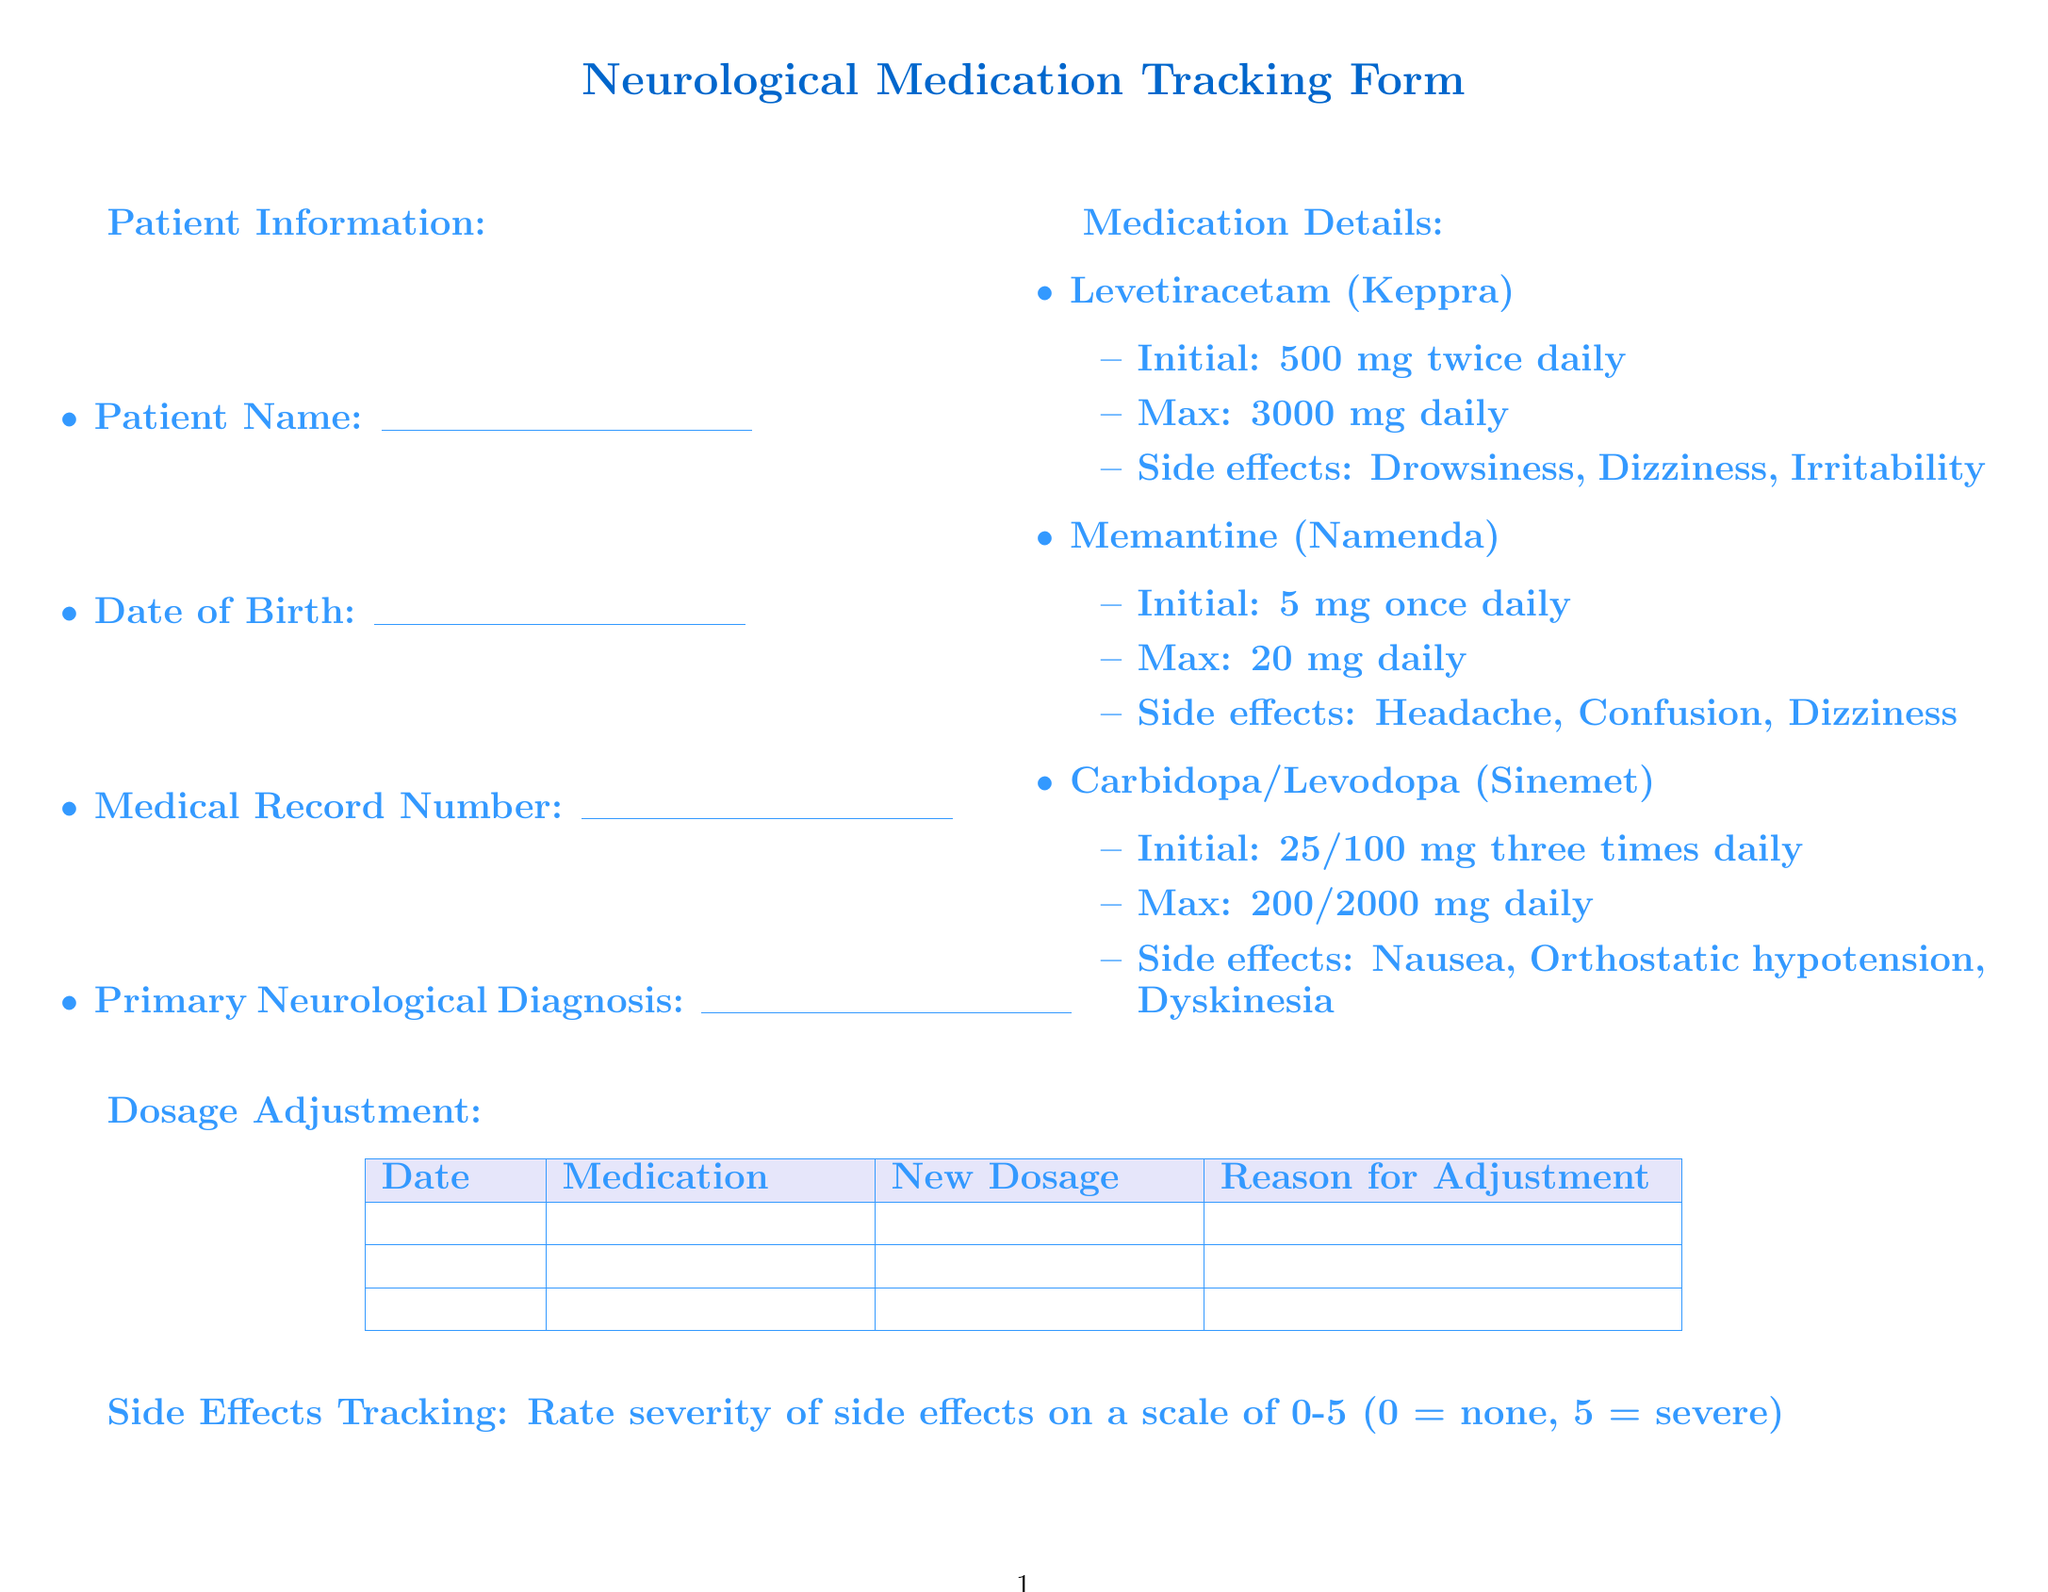what is the title of the form? The title of the form is presented at the top of the document as the main heading.
Answer: Neurological Medication Tracking Form what is the initial dosage of Levetiracetam? The initial dosage is listed under the medication details for Levetiracetam.
Answer: 500 mg twice daily what type of side effect is associated with Memantine? The common side effects for Memantine are listed in bullet points under its medication details.
Answer: Headache how many rows are available for dosage adjustments? The number of rows for dosage adjustments is mentioned in the table under the dosage adjustment section.
Answer: 10 what is the maximum dosage for Carbidopa/Levodopa? The maximum dosage is specified in the medication details under Carbidopa/Levodopa.
Answer: 200/2000 mg daily which cognitive assessment tools are included? The cognitive assessment tools are listed in the patient response section.
Answer: Mini-Mental State Examination, Montreal Cognitive Assessment, Clock Drawing Test how often should the liver function tests be performed? The document includes lab tests but does not indicate the frequency.
Answer: Not specified what option indicates no seizures? The seizure frequency options include various frequencies, one of which indicates no seizures.
Answer: No seizures what is the follow-up plan's next appointment? The next appointment is specified as a section where the date can be filled.
Answer: Date: ________ 